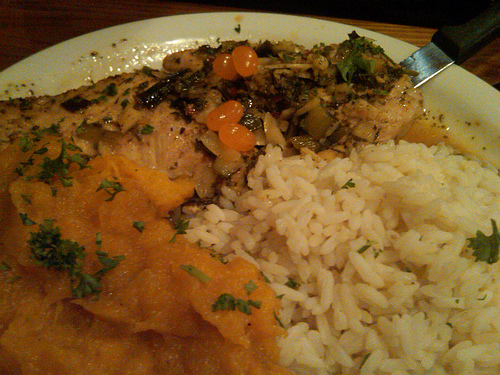<image>
Can you confirm if the rice is on the plate? Yes. Looking at the image, I can see the rice is positioned on top of the plate, with the plate providing support. 